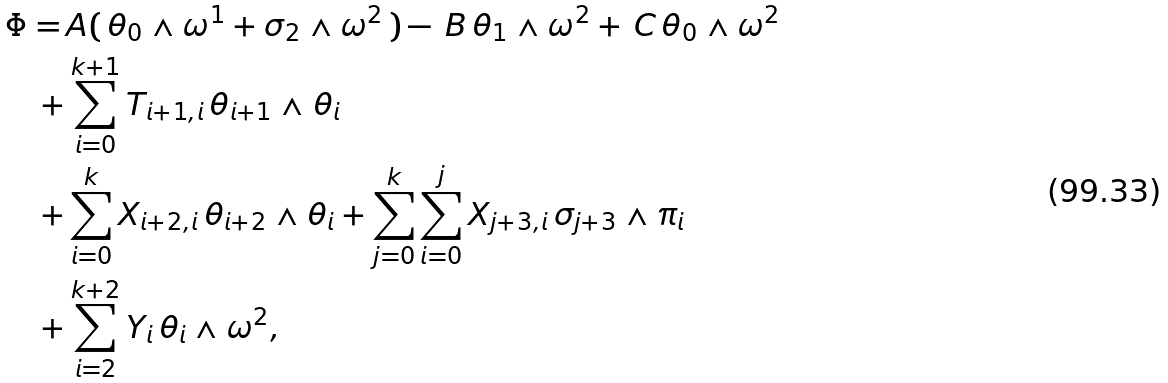Convert formula to latex. <formula><loc_0><loc_0><loc_500><loc_500>\Phi = \, & A ( \, \theta _ { 0 } \wedge \omega ^ { 1 } + \sigma _ { 2 } \wedge \omega ^ { 2 } \, ) - \, B \, \theta _ { 1 } \wedge \omega ^ { 2 } + \, C \, \theta _ { 0 } \wedge \omega ^ { 2 } \\ + & \sum _ { i = 0 } ^ { k + 1 } T _ { i + 1 , i } \, \theta _ { i + 1 } \wedge \theta _ { i } \\ + & \sum _ { i = 0 } ^ { k } X _ { i + 2 , i } \, \theta _ { i + 2 } \wedge \theta _ { i } + \sum _ { j = 0 } ^ { k } \sum _ { i = 0 } ^ { j } X _ { j + 3 , i } \, \sigma _ { j + 3 } \wedge \pi _ { i } \\ + & \sum _ { i = 2 } ^ { k + 2 } Y _ { i } \, \theta _ { i } \wedge \omega ^ { 2 } ,</formula> 